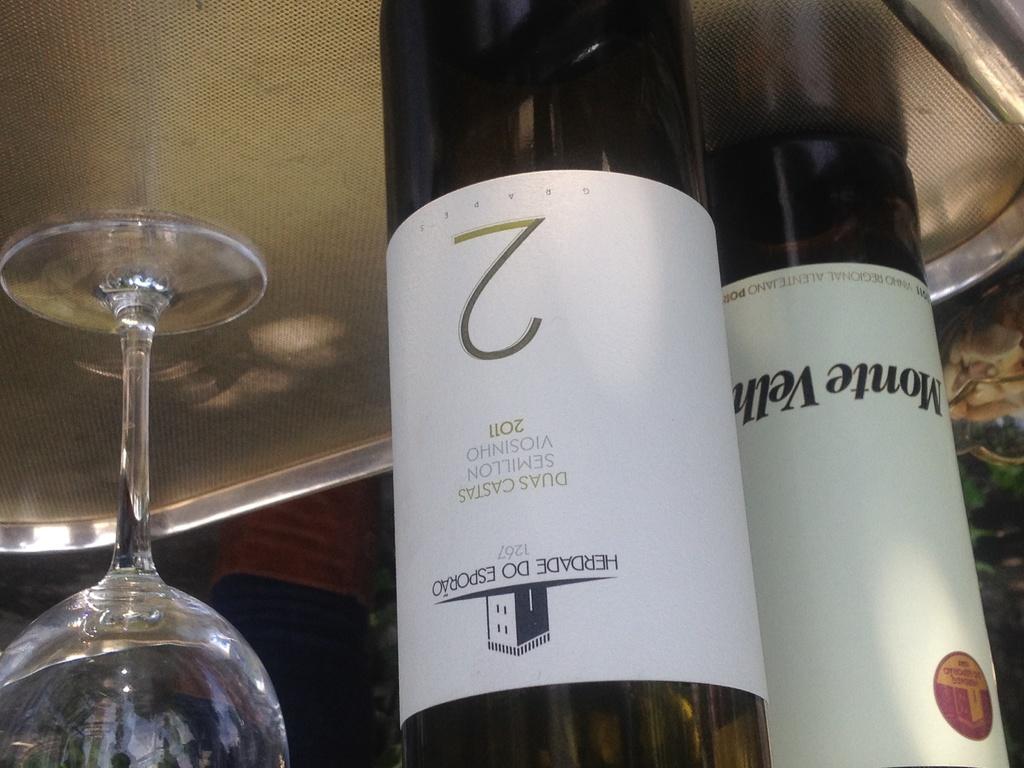What year was this wine produced?
Provide a short and direct response. 2011. What number is on the bottle?
Offer a very short reply. 2. 